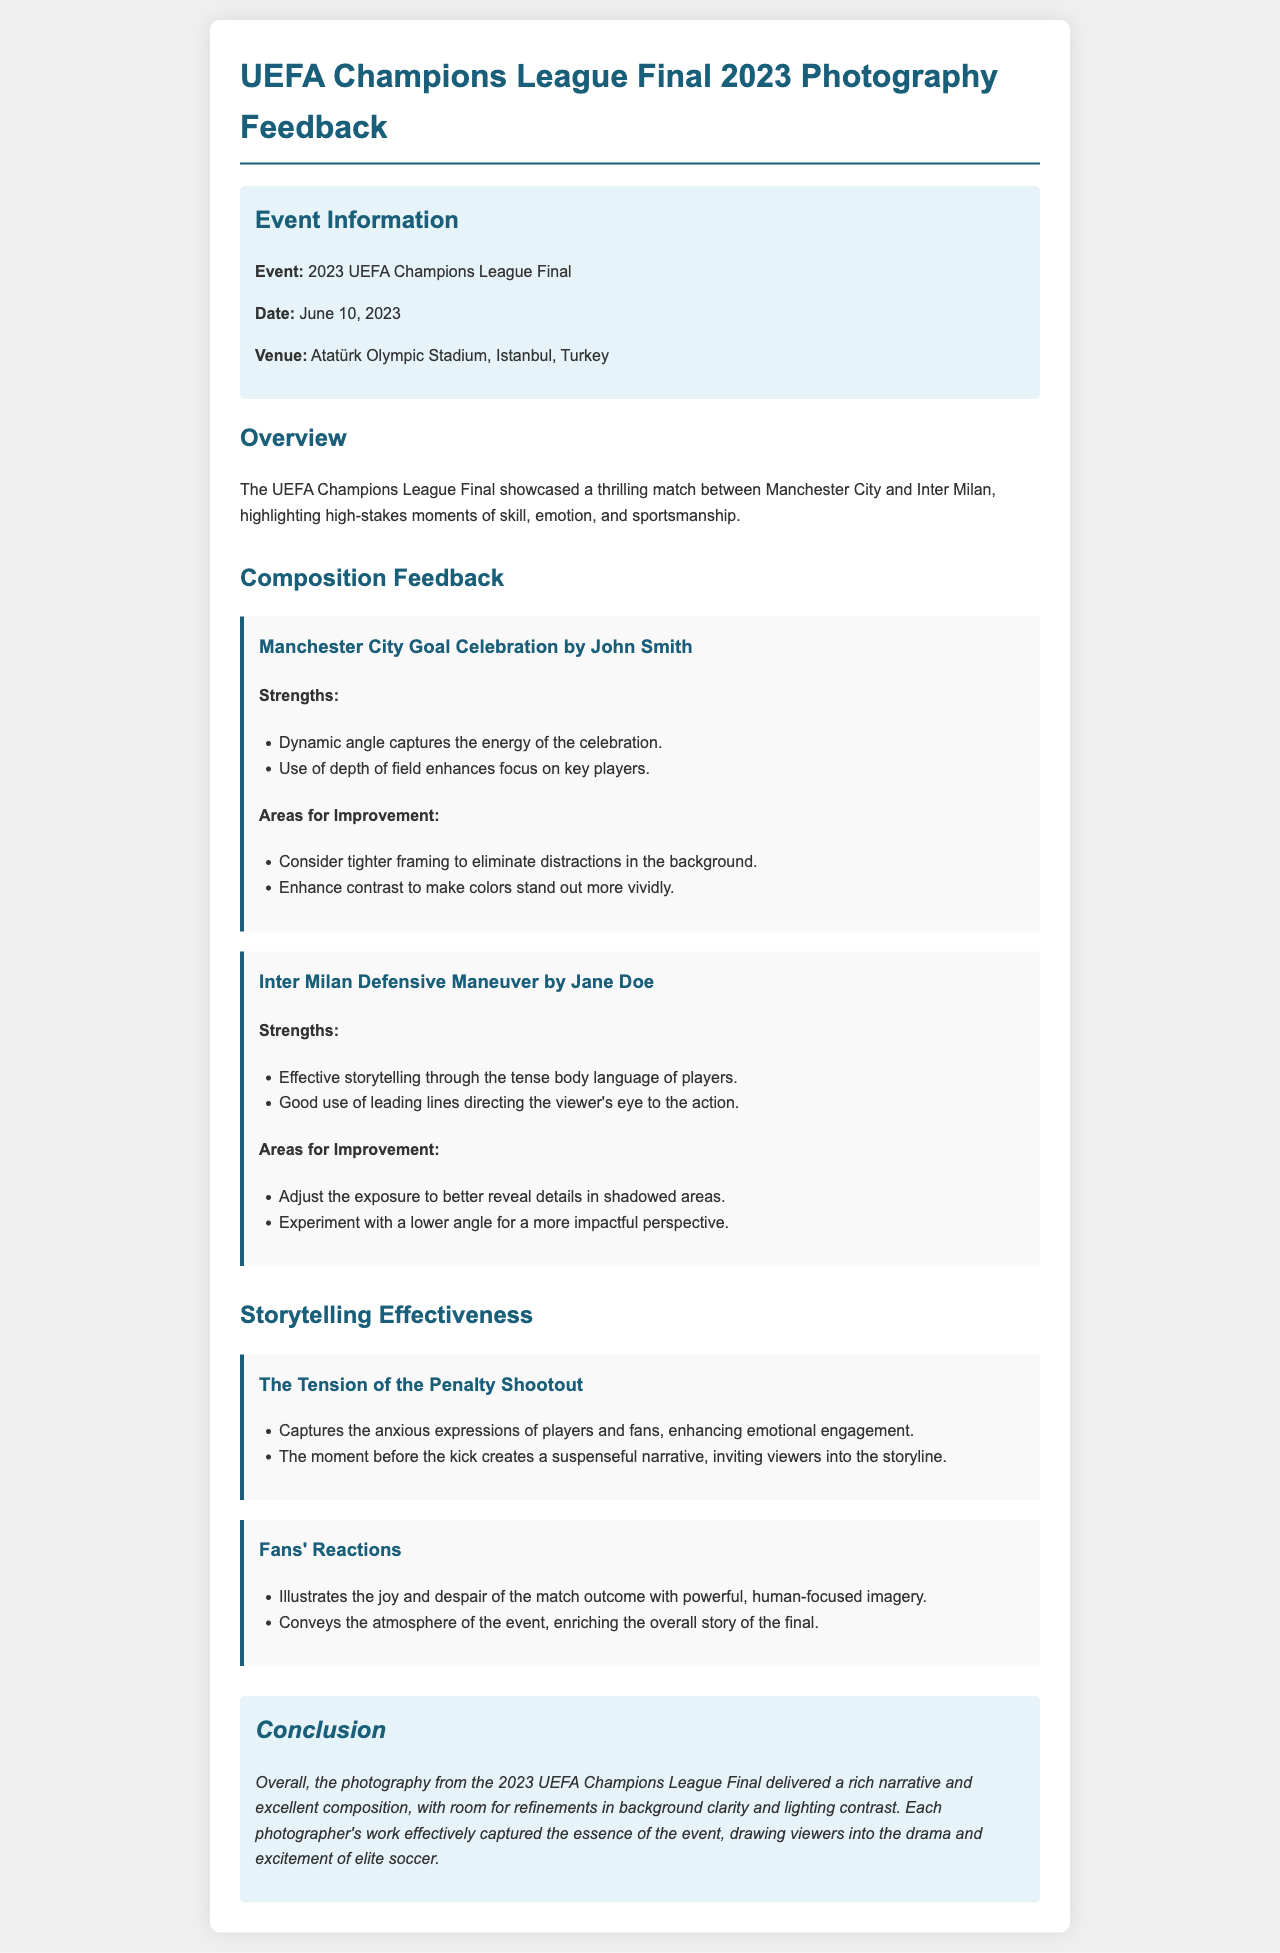What is the event featured in the document? The document discusses the photography feedback for a specific sports event, which is identified as the UEFA Champions League Final.
Answer: UEFA Champions League Final When did the event take place? The document clearly states the date of the event, which is a specific day in June 2023.
Answer: June 10, 2023 Who is the photographer of the Manchester City goal celebration photo? The document specifies the name of the photographer who captured a particular moment during the event in relation to Manchester City’s goal.
Answer: John Smith What aspect of the Inter Milan photo requires adjustment? The feedback includes areas for improvement specifically related to exposure in the Inter Milan photo captured by Jane Doe.
Answer: Exposure What is highlighted in the storytelling effectiveness section? The document discusses two significant moments that illustrate the emotional engagement of fans and players during the match.
Answer: Tension of the Penalty Shootout How does the feedback describe the overall photography from the event? The conclusion summarizes the general quality of the photography, emphasizing narrative and composition strengths while noting areas for improvement.
Answer: Rich narrative and excellent composition Which venue hosted the UEFA Champions League Final 2023? The document provides the location where the event took place, specifying it in the event details.
Answer: Atatürk Olympic Stadium, Istanbul, Turkey What photographic element enhances focus on key players in the goal celebration photo? The strengths section mentions specific technical aspects that contribute to the composition of the photograph.
Answer: Depth of field What main emotion is captured during the penalty shootout in the photography? The document details the emotional expressions depicted, emphasizing the atmosphere surrounding a crucial moment of the match.
Answer: Anxious expressions 